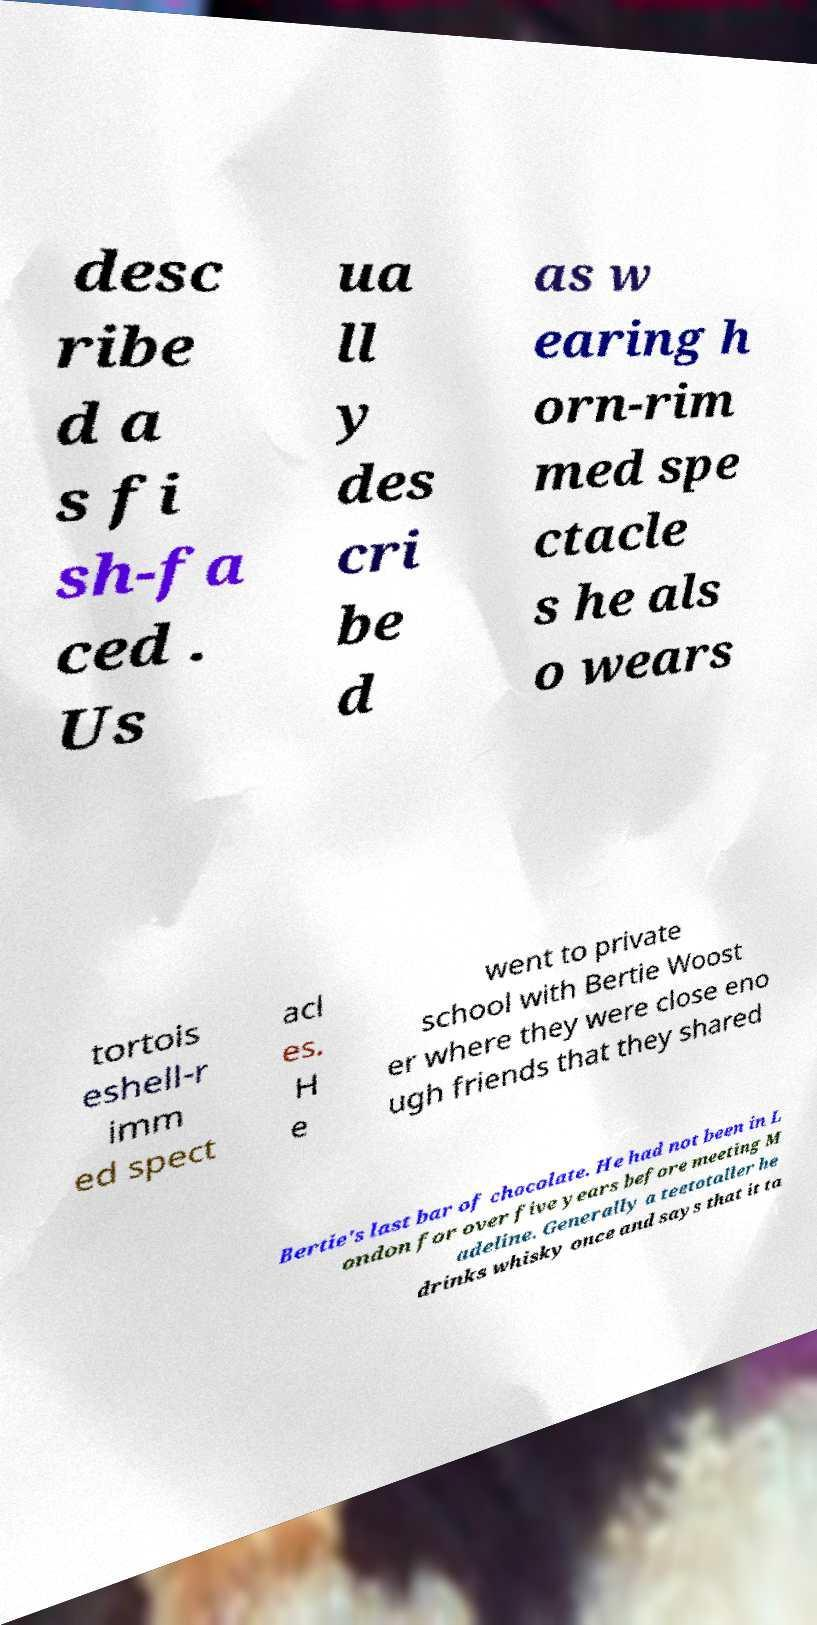Please identify and transcribe the text found in this image. desc ribe d a s fi sh-fa ced . Us ua ll y des cri be d as w earing h orn-rim med spe ctacle s he als o wears tortois eshell-r imm ed spect acl es. H e went to private school with Bertie Woost er where they were close eno ugh friends that they shared Bertie's last bar of chocolate. He had not been in L ondon for over five years before meeting M adeline. Generally a teetotaller he drinks whisky once and says that it ta 